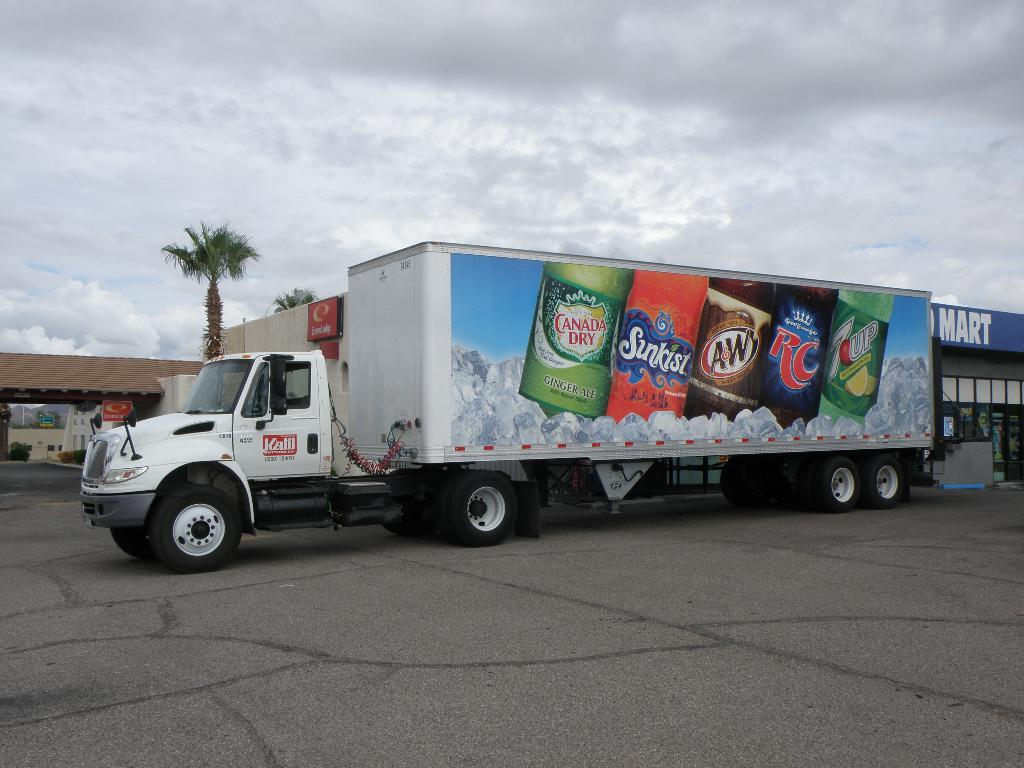What is located in the middle of the picture? There is a container in the middle of the picture. What can be seen on the left side of the picture? There are two trees on the left side of the picture. What is visible in the sky in the background of the image? There are clouds visible in the sky in the background of the image. Who is the creator of the lip seen in the image? There is no lip present in the image, so it is not possible to determine the creator. 